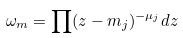Convert formula to latex. <formula><loc_0><loc_0><loc_500><loc_500>\omega _ { m } = \prod ( z - m _ { j } ) ^ { - \mu _ { j } } d z</formula> 